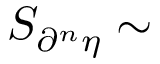Convert formula to latex. <formula><loc_0><loc_0><loc_500><loc_500>S _ { \partial ^ { n } { \eta } } \sim</formula> 